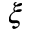Convert formula to latex. <formula><loc_0><loc_0><loc_500><loc_500>\xi</formula> 